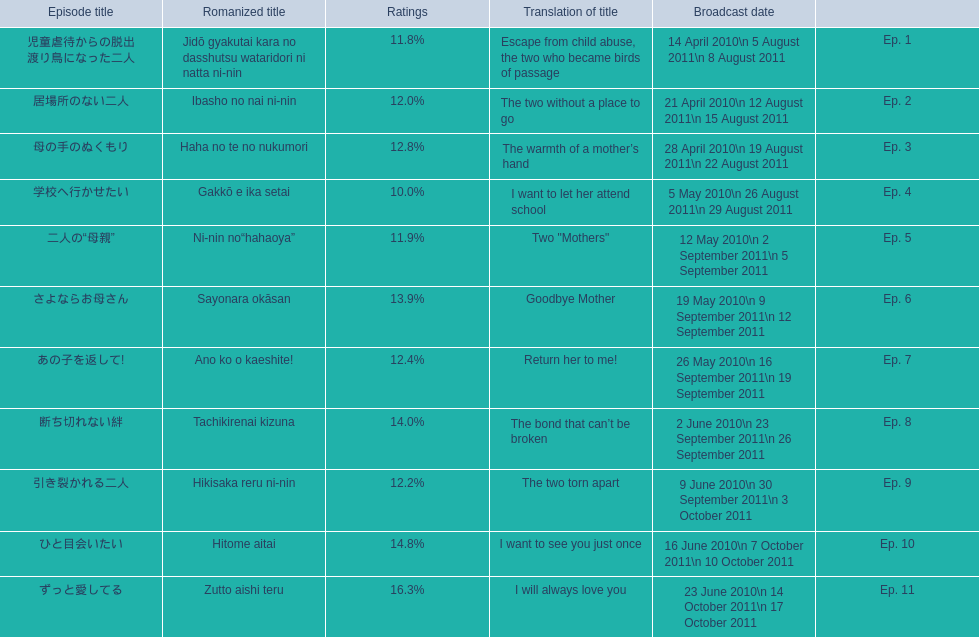What is the name of epsiode 8? 断ち切れない絆. What were this episodes ratings? 14.0%. 